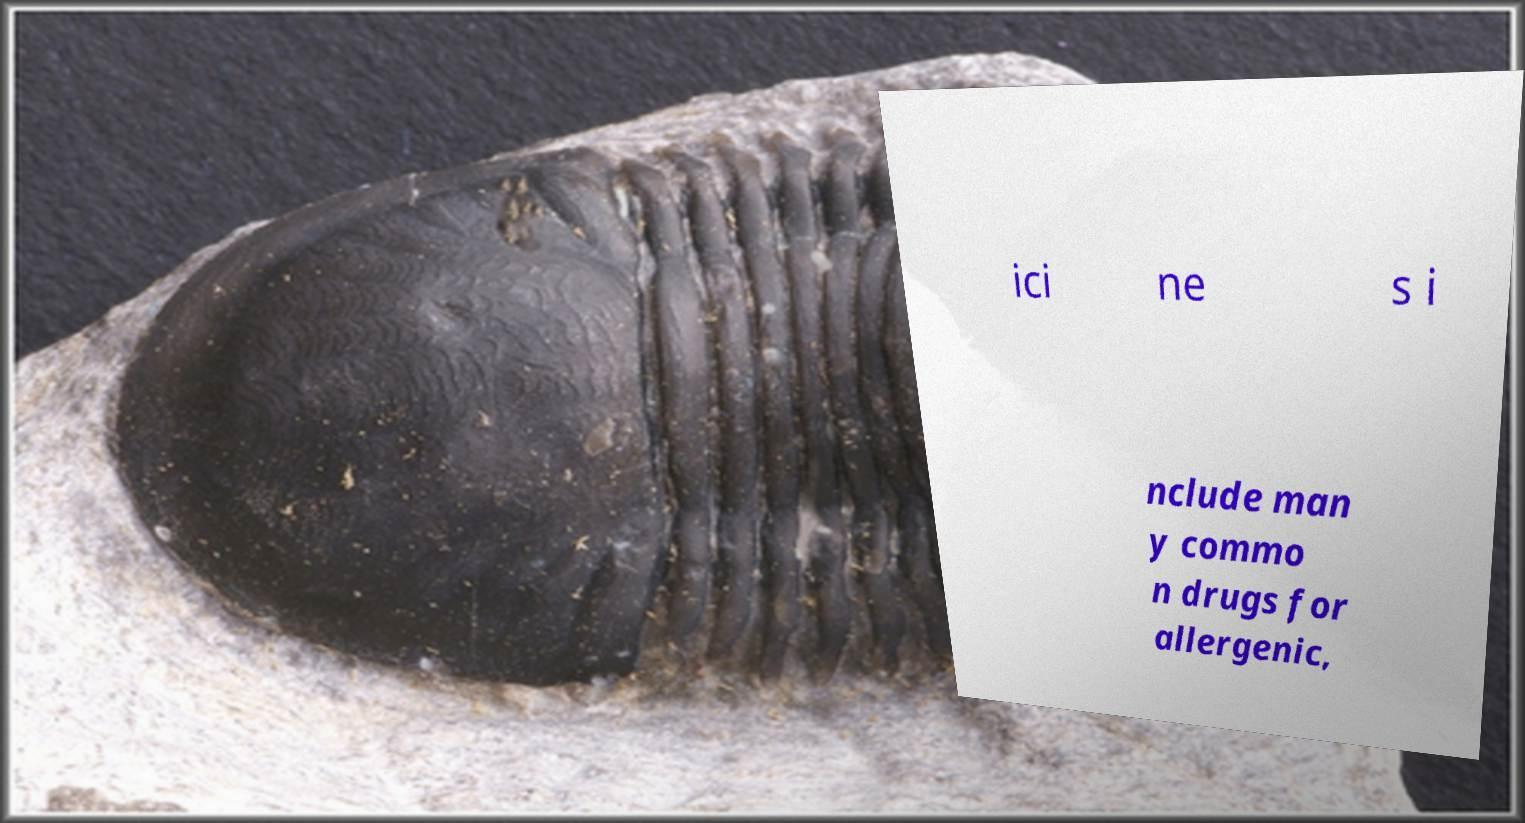Please identify and transcribe the text found in this image. ici ne s i nclude man y commo n drugs for allergenic, 